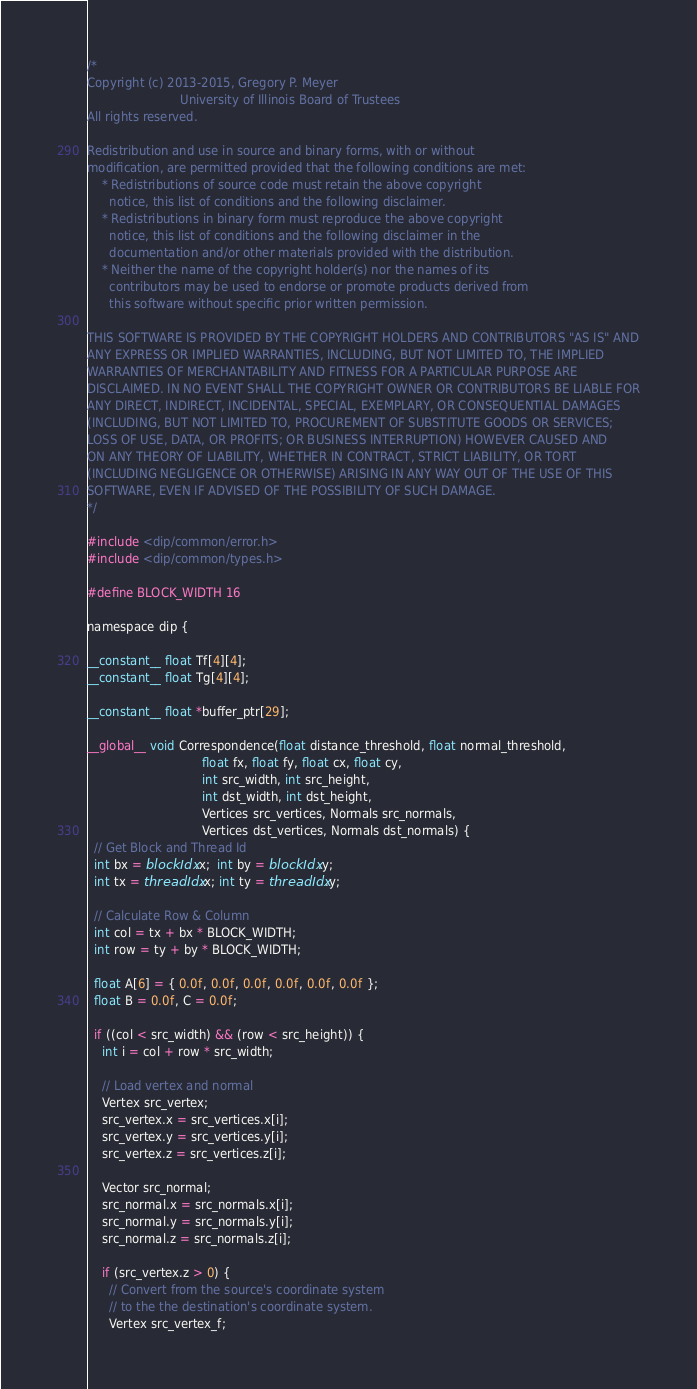<code> <loc_0><loc_0><loc_500><loc_500><_Cuda_>/*
Copyright (c) 2013-2015, Gregory P. Meyer
                         University of Illinois Board of Trustees
All rights reserved.

Redistribution and use in source and binary forms, with or without
modification, are permitted provided that the following conditions are met:
    * Redistributions of source code must retain the above copyright
      notice, this list of conditions and the following disclaimer.
    * Redistributions in binary form must reproduce the above copyright
      notice, this list of conditions and the following disclaimer in the
      documentation and/or other materials provided with the distribution.
    * Neither the name of the copyright holder(s) nor the names of its
      contributors may be used to endorse or promote products derived from
      this software without specific prior written permission.

THIS SOFTWARE IS PROVIDED BY THE COPYRIGHT HOLDERS AND CONTRIBUTORS "AS IS" AND
ANY EXPRESS OR IMPLIED WARRANTIES, INCLUDING, BUT NOT LIMITED TO, THE IMPLIED
WARRANTIES OF MERCHANTABILITY AND FITNESS FOR A PARTICULAR PURPOSE ARE
DISCLAIMED. IN NO EVENT SHALL THE COPYRIGHT OWNER OR CONTRIBUTORS BE LIABLE FOR
ANY DIRECT, INDIRECT, INCIDENTAL, SPECIAL, EXEMPLARY, OR CONSEQUENTIAL DAMAGES
(INCLUDING, BUT NOT LIMITED TO, PROCUREMENT OF SUBSTITUTE GOODS OR SERVICES;
LOSS OF USE, DATA, OR PROFITS; OR BUSINESS INTERRUPTION) HOWEVER CAUSED AND
ON ANY THEORY OF LIABILITY, WHETHER IN CONTRACT, STRICT LIABILITY, OR TORT
(INCLUDING NEGLIGENCE OR OTHERWISE) ARISING IN ANY WAY OUT OF THE USE OF THIS
SOFTWARE, EVEN IF ADVISED OF THE POSSIBILITY OF SUCH DAMAGE.
*/

#include <dip/common/error.h>
#include <dip/common/types.h>

#define BLOCK_WIDTH 16

namespace dip {

__constant__ float Tf[4][4];
__constant__ float Tg[4][4];

__constant__ float *buffer_ptr[29];

__global__ void Correspondence(float distance_threshold, float normal_threshold,
                               float fx, float fy, float cx, float cy,
                               int src_width, int src_height,
                               int dst_width, int dst_height,
                               Vertices src_vertices, Normals src_normals,
                               Vertices dst_vertices, Normals dst_normals) {
  // Get Block and Thread Id
  int bx = blockIdx.x;  int by = blockIdx.y;
  int tx = threadIdx.x; int ty = threadIdx.y;

  // Calculate Row & Column
  int col = tx + bx * BLOCK_WIDTH;
  int row = ty + by * BLOCK_WIDTH;

  float A[6] = { 0.0f, 0.0f, 0.0f, 0.0f, 0.0f, 0.0f };
  float B = 0.0f, C = 0.0f;

  if ((col < src_width) && (row < src_height)) {
    int i = col + row * src_width;

    // Load vertex and normal
    Vertex src_vertex;
    src_vertex.x = src_vertices.x[i];
    src_vertex.y = src_vertices.y[i];
    src_vertex.z = src_vertices.z[i];

    Vector src_normal;
    src_normal.x = src_normals.x[i];
    src_normal.y = src_normals.y[i];
    src_normal.z = src_normals.z[i];

    if (src_vertex.z > 0) {
      // Convert from the source's coordinate system
      // to the the destination's coordinate system.
      Vertex src_vertex_f;
</code> 